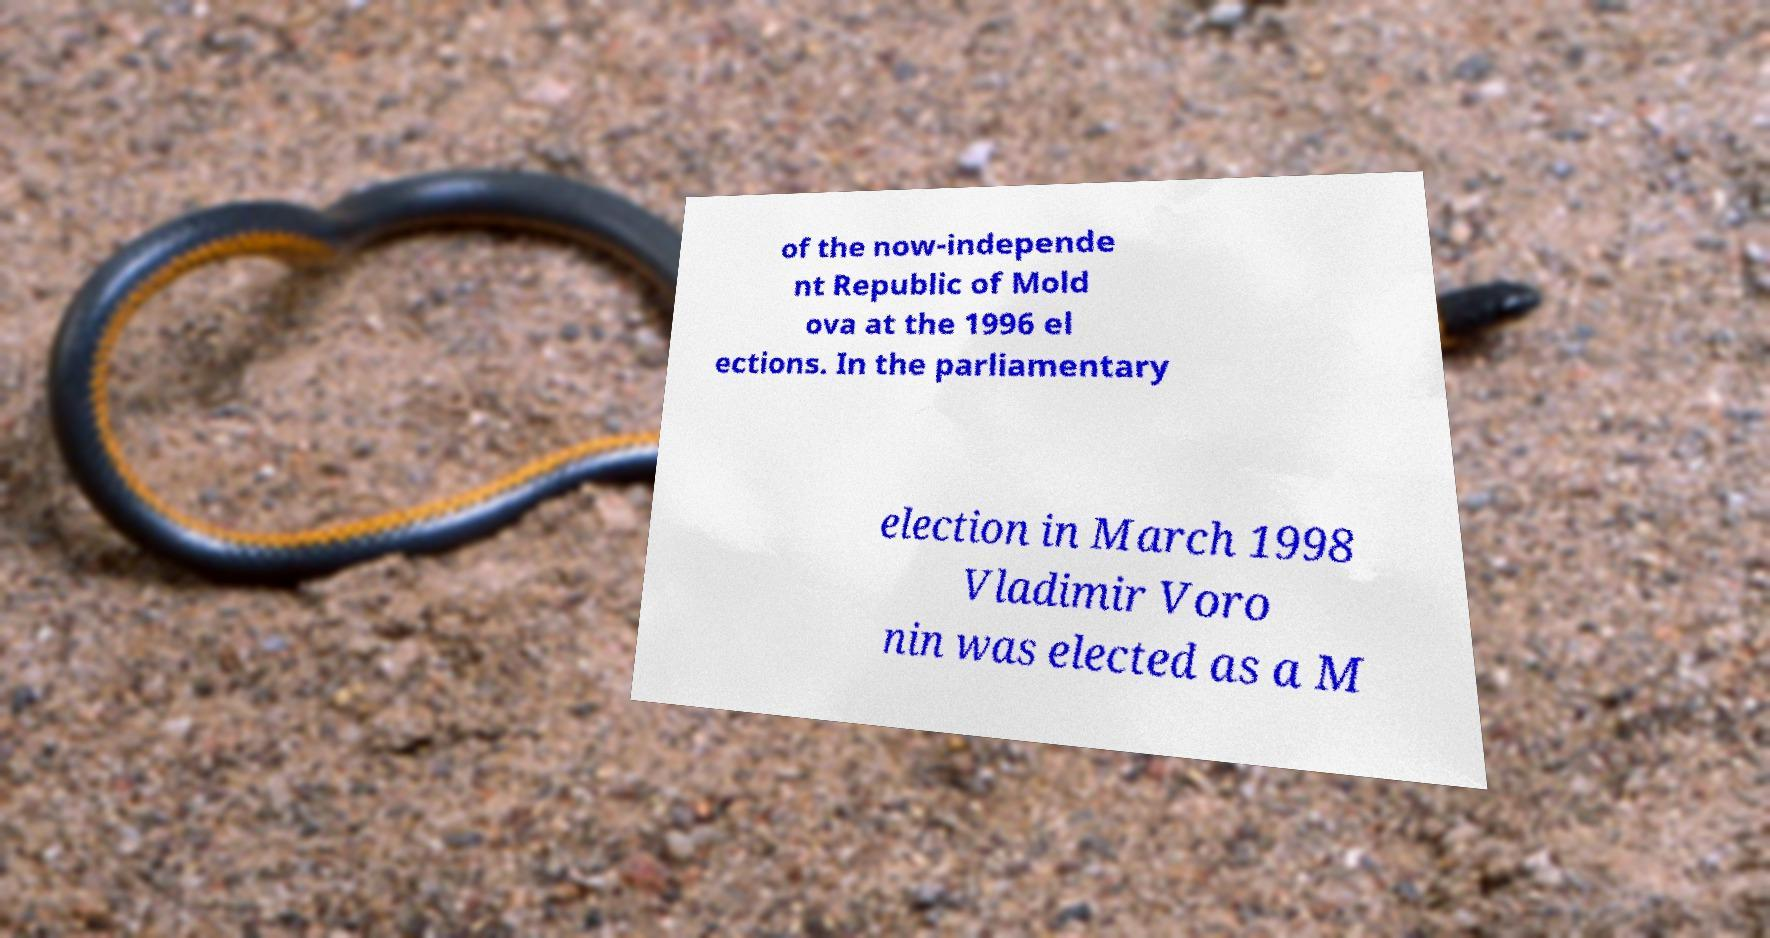What messages or text are displayed in this image? I need them in a readable, typed format. of the now-independe nt Republic of Mold ova at the 1996 el ections. In the parliamentary election in March 1998 Vladimir Voro nin was elected as a M 